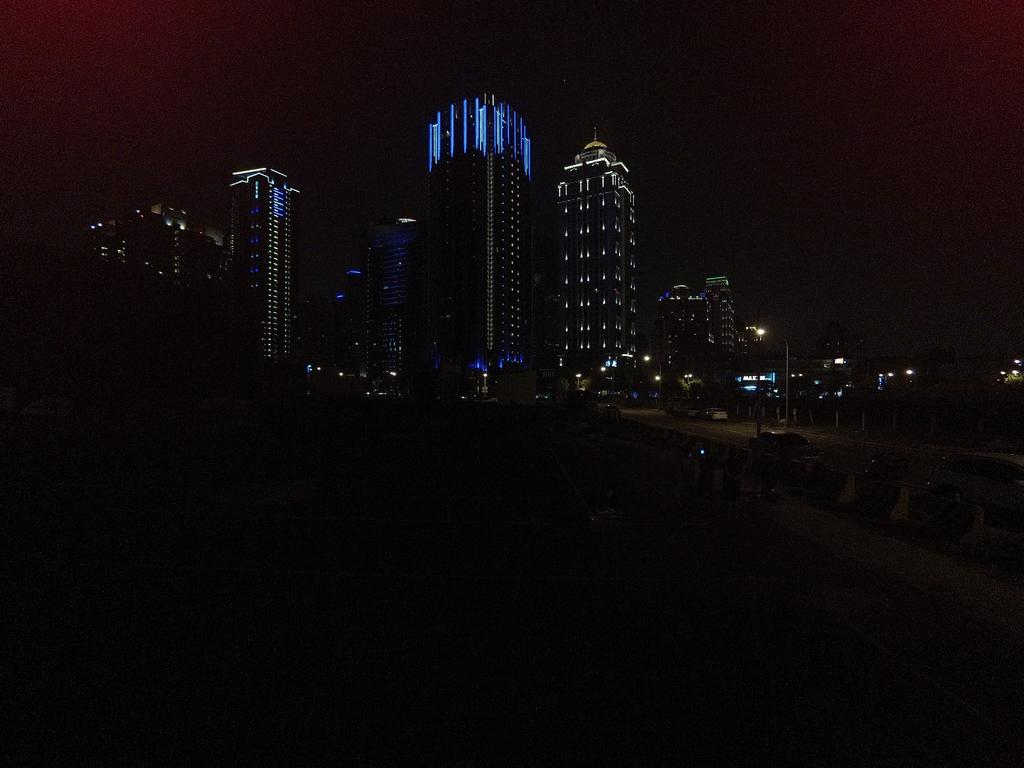What can be seen in the background of the image? There are many buildings in the background of the image. What feature do the buildings have? The buildings have lights. What is on the left side of the image? There is a road on the left side of the image. What is happening on the road? Vehicles are moving on the road. When was the image taken? The image was taken at night time. Can you see a toad combing its hair in the image? There is no toad or comb present in the image. What type of vacation is being taken in the image? The image does not depict a vacation; it shows a road with vehicles and buildings in the background. 